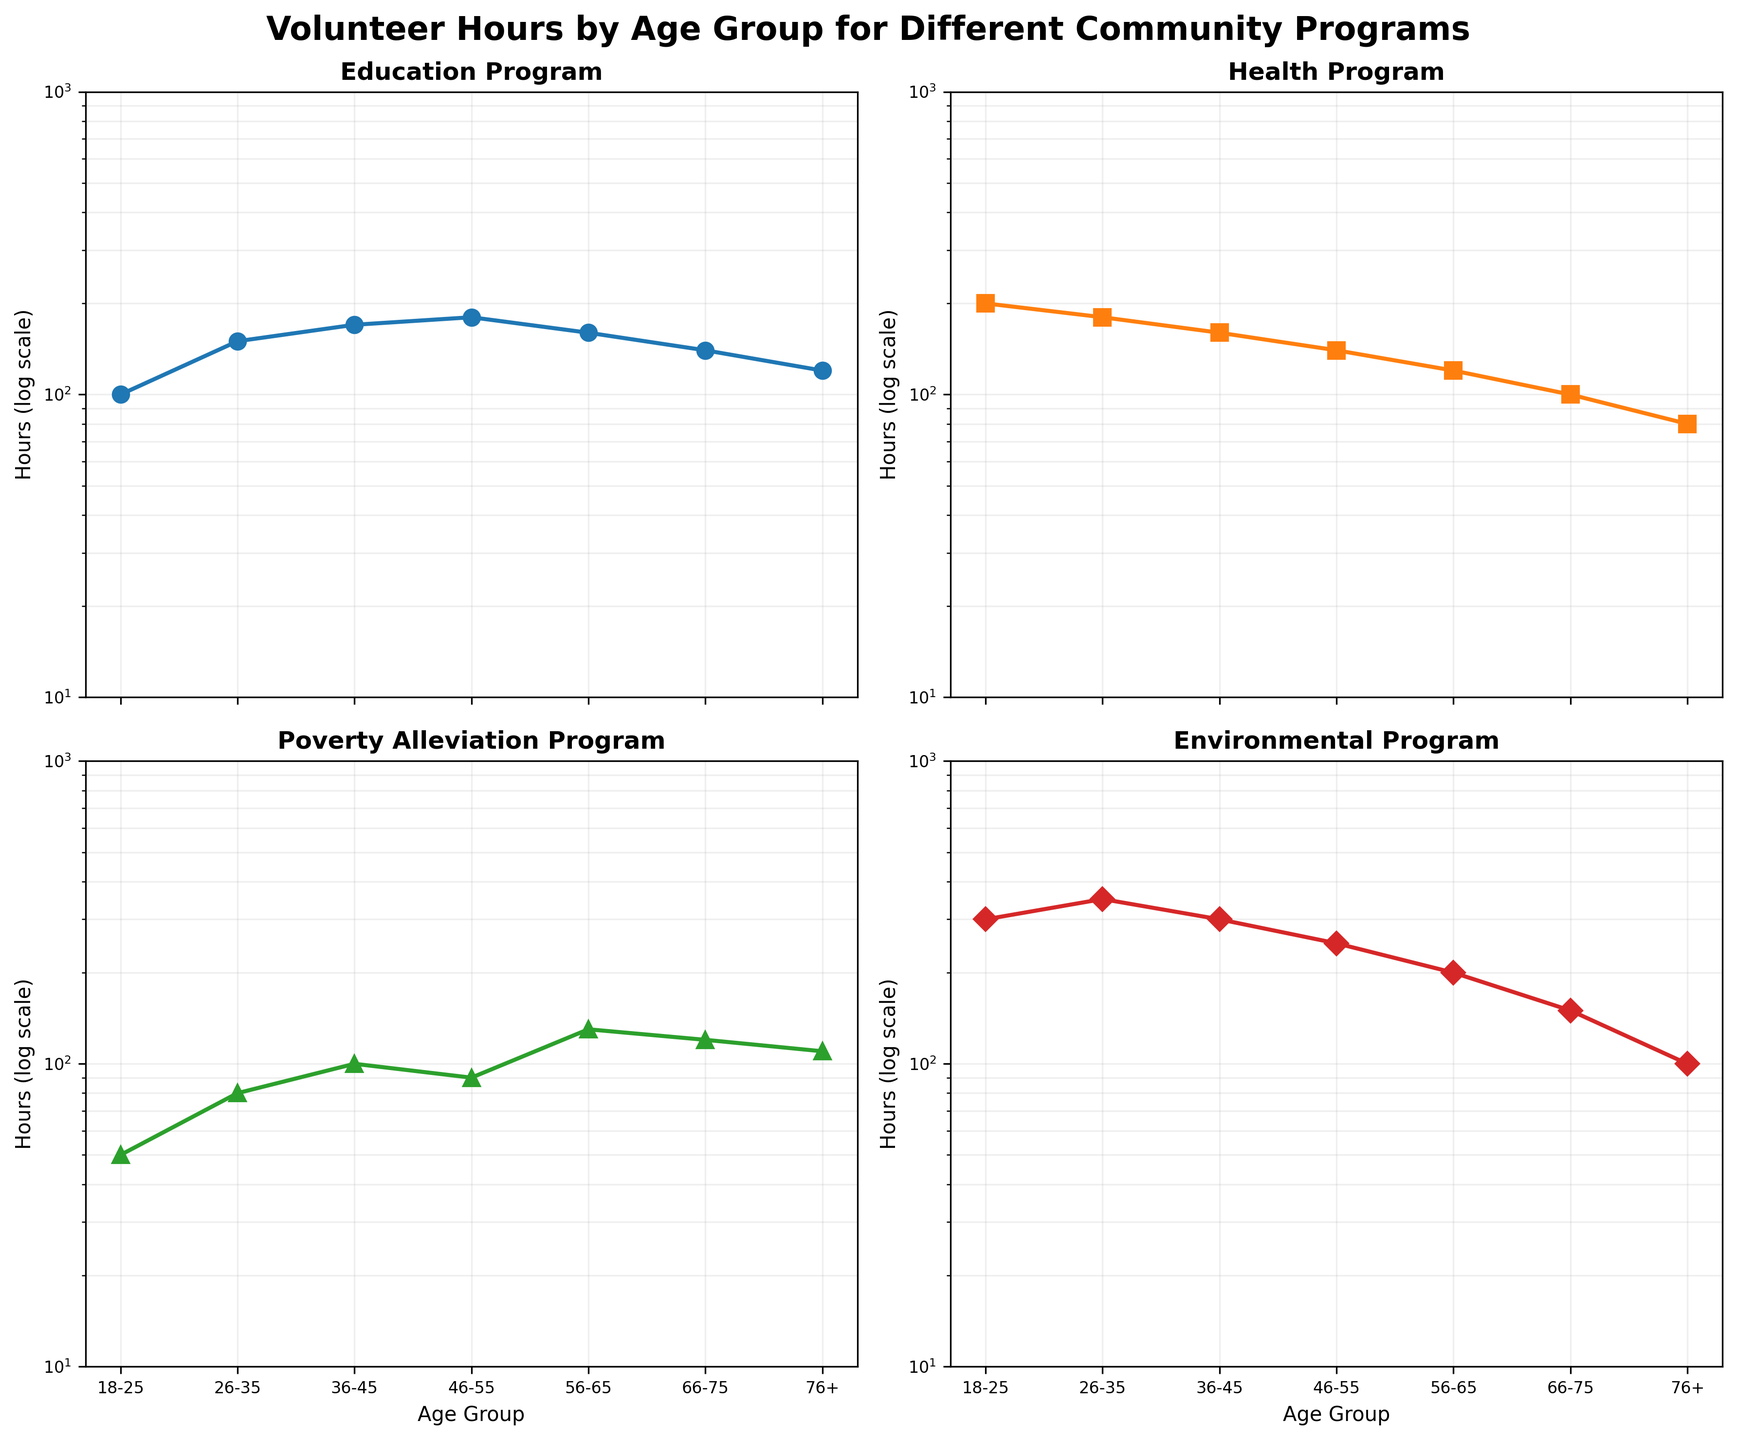what is the title of the figure? The title of the figure is usually located at the top of the chart. In this case, it reads: "Volunteer Hours by Age Group for Different Community Programs"
Answer: Volunteer Hours by Age Group for Different Community Programs What is the range of hours on the y-axis for the Environmental Program subplot? By looking at the y-axis for the Environmental Program subplot, we can see that it ranges from 10 to 1000 hours on a logarithmic scale.
Answer: 10 to 1000 hours Which age group volunteered the most hours for the Health Program? By examining the Health Program subplot, we see that the 18-25 age group (the first point on the x-axis) has the highest value of hours.
Answer: 18-25 How do the volunteer hours for the Education Program change as age increases? By following the line for the Education Program from left to right across the x-axis (younger to older age groups), we see a general downward trend in the volunteer hours.
Answer: Decrease How do the volunteer hours for the 26-35 age group compare between the Education and Poverty Alleviation Programs? We need to compare the second data point on the x-axis between the two subplots. For the Education Program, the value is 150 hours, and for the Poverty Alleviation Program, it is 80 hours.
Answer: Education has more hours What is the average number of volunteer hours dedicated to the Health Program across all age groups? To find the average, we sum the following values: 200, 180, 160, 140, 120, 100, and 80. The sum is 980 hours. Then, we divide by the number of age groups, which is 7: 980/7. The average is approximately 140 hours.
Answer: 140 hours Which age group has the highest number of volunteer hours for the Education Program? Examine the points on the Education Program subplot. The highest value is for the 46-55 age group (180 hours).
Answer: 46-55 What trend do you notice in the Poverty Alleviation Program hours as age progresses from 18-25 to 76+? By following the data points from left to right, we observe initial increase in hours up to 56-65 age group and then a slight decrease.
Answer: Increase then decrease Which program shows the most consistent volunteer hours across all age groups? By comparing the fluctuations in each subplot, the Health Program graph shows the most consistent levels of volunteer hours across the age groups.
Answer: Health Program Between the age groups 66-75 and 76+, how does the trend differ for the volunteer hours in the Environmental Program? By observing the y-values for the last two data points on the Environmental Program subplot, we see a decrease from 150 hours in the 66-75 age group to 100 hours in the 76+ age group.
Answer: Decrease 